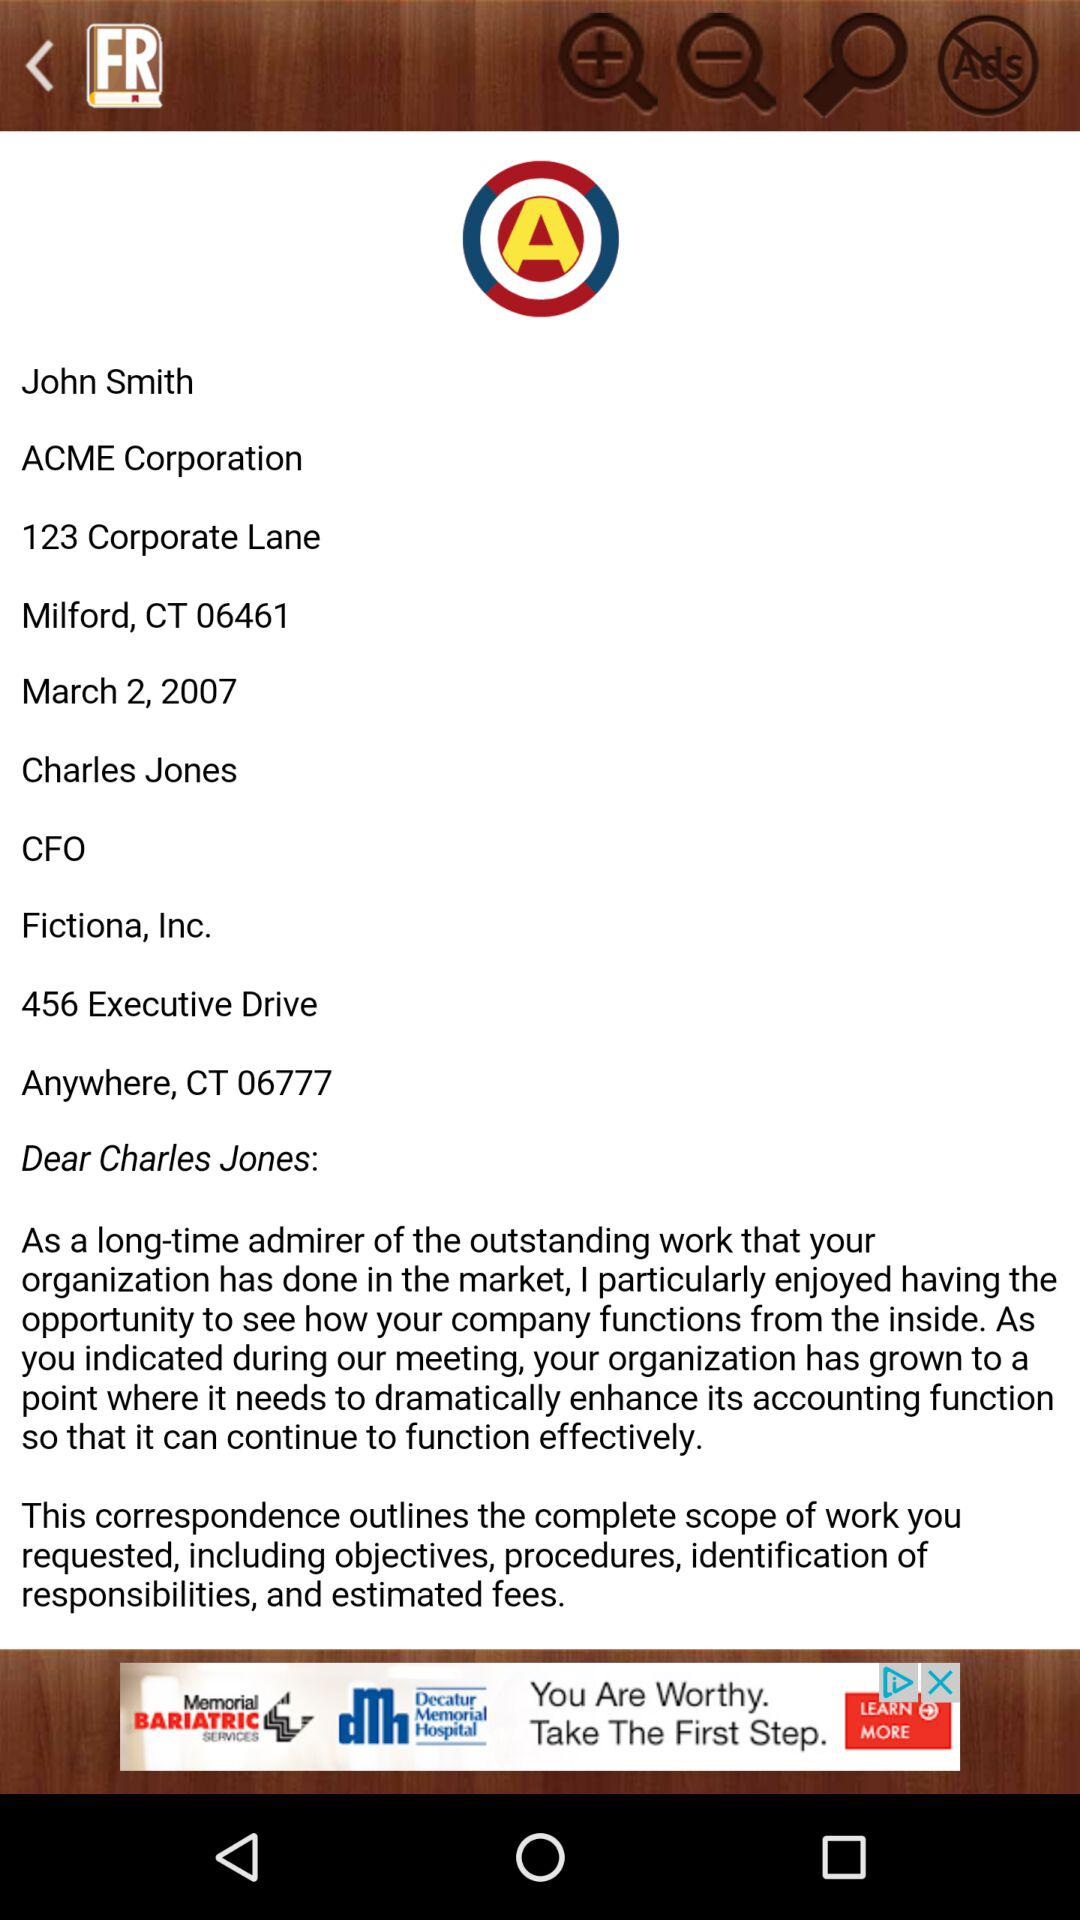What is the given address of the sender? The address of the sender is ACME Corporation, 123 Corporate Lane, Milford, CT 06461. 